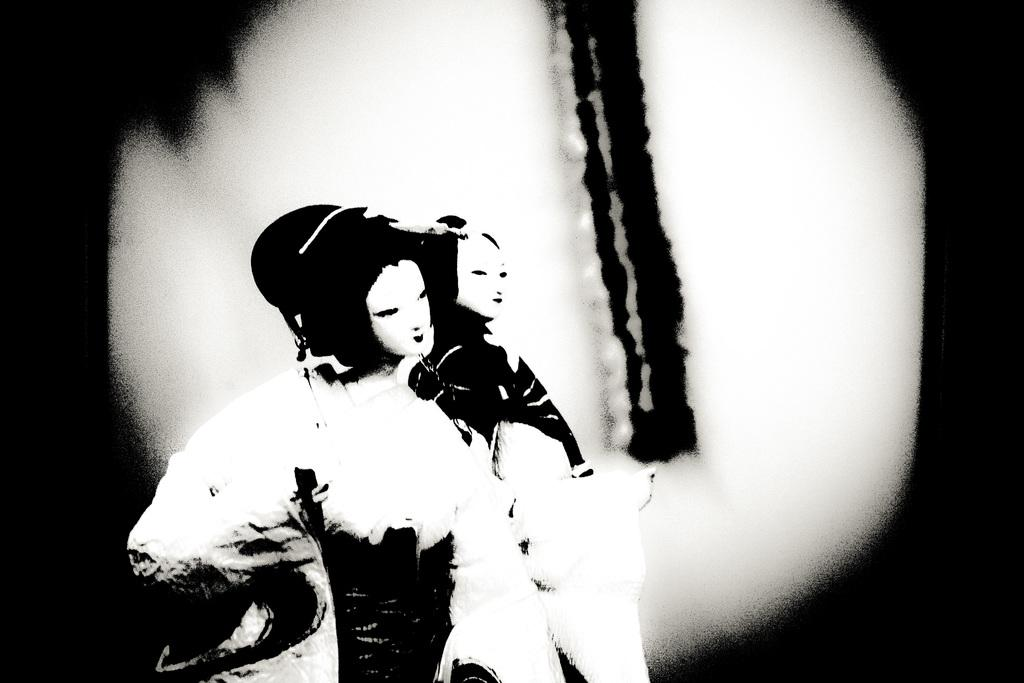What can be observed about the image itself? The image appears to be edited. What is happening in the center of the image? There are two persons standing in the middle of the image. What are the persons wearing? Both persons are wearing face masks. Can you tell me how many calculators are visible in the image? There are no calculators present in the image. What type of boat can be seen in the background of the image? There is no boat visible in the image. 